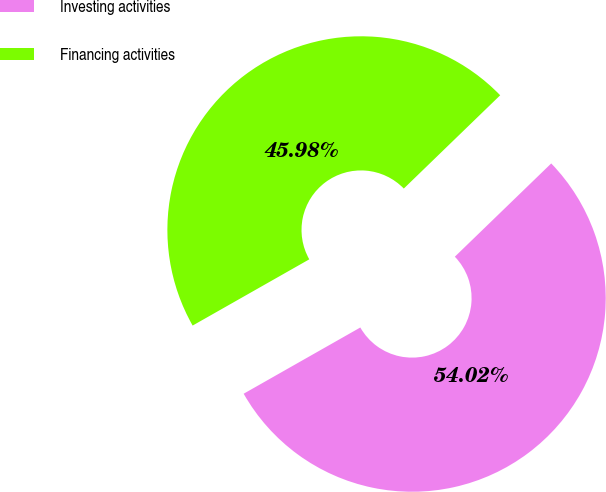Convert chart. <chart><loc_0><loc_0><loc_500><loc_500><pie_chart><fcel>Investing activities<fcel>Financing activities<nl><fcel>54.02%<fcel>45.98%<nl></chart> 